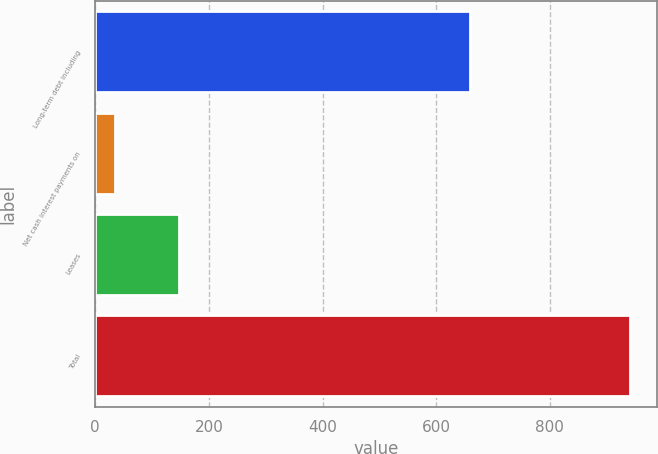<chart> <loc_0><loc_0><loc_500><loc_500><bar_chart><fcel>Long-term debt including<fcel>Net cash interest payments on<fcel>Leases<fcel>Total<nl><fcel>660<fcel>35<fcel>148<fcel>942<nl></chart> 